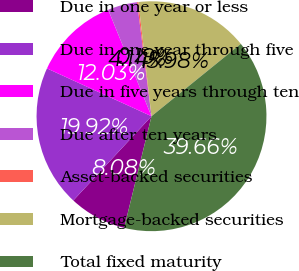<chart> <loc_0><loc_0><loc_500><loc_500><pie_chart><fcel>Due in one year or less<fcel>Due in one year through five<fcel>Due in five years through ten<fcel>Due after ten years<fcel>Asset-backed securities<fcel>Mortgage-backed securities<fcel>Total fixed maturity<nl><fcel>8.08%<fcel>19.92%<fcel>12.03%<fcel>4.14%<fcel>0.19%<fcel>15.98%<fcel>39.66%<nl></chart> 